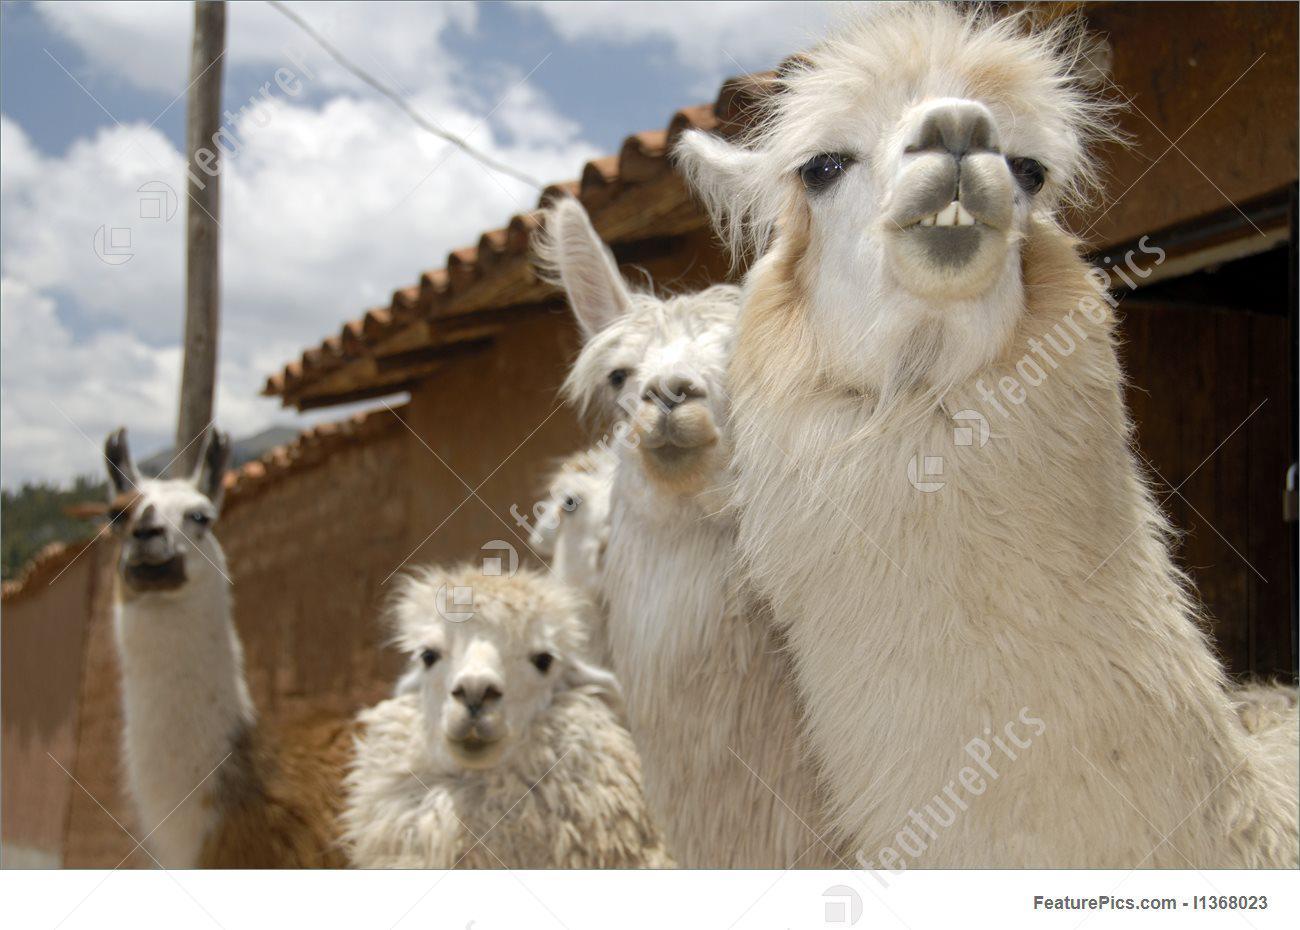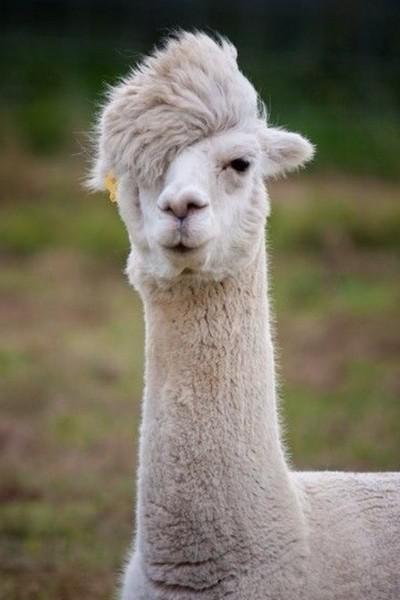The first image is the image on the left, the second image is the image on the right. Given the left and right images, does the statement "In one image there is a person standing next to a llama and in the other image there is a llama decorated with yarn." hold true? Answer yes or no. No. The first image is the image on the left, the second image is the image on the right. For the images shown, is this caption "LLamas are showing off their colorful and festive attire." true? Answer yes or no. No. 